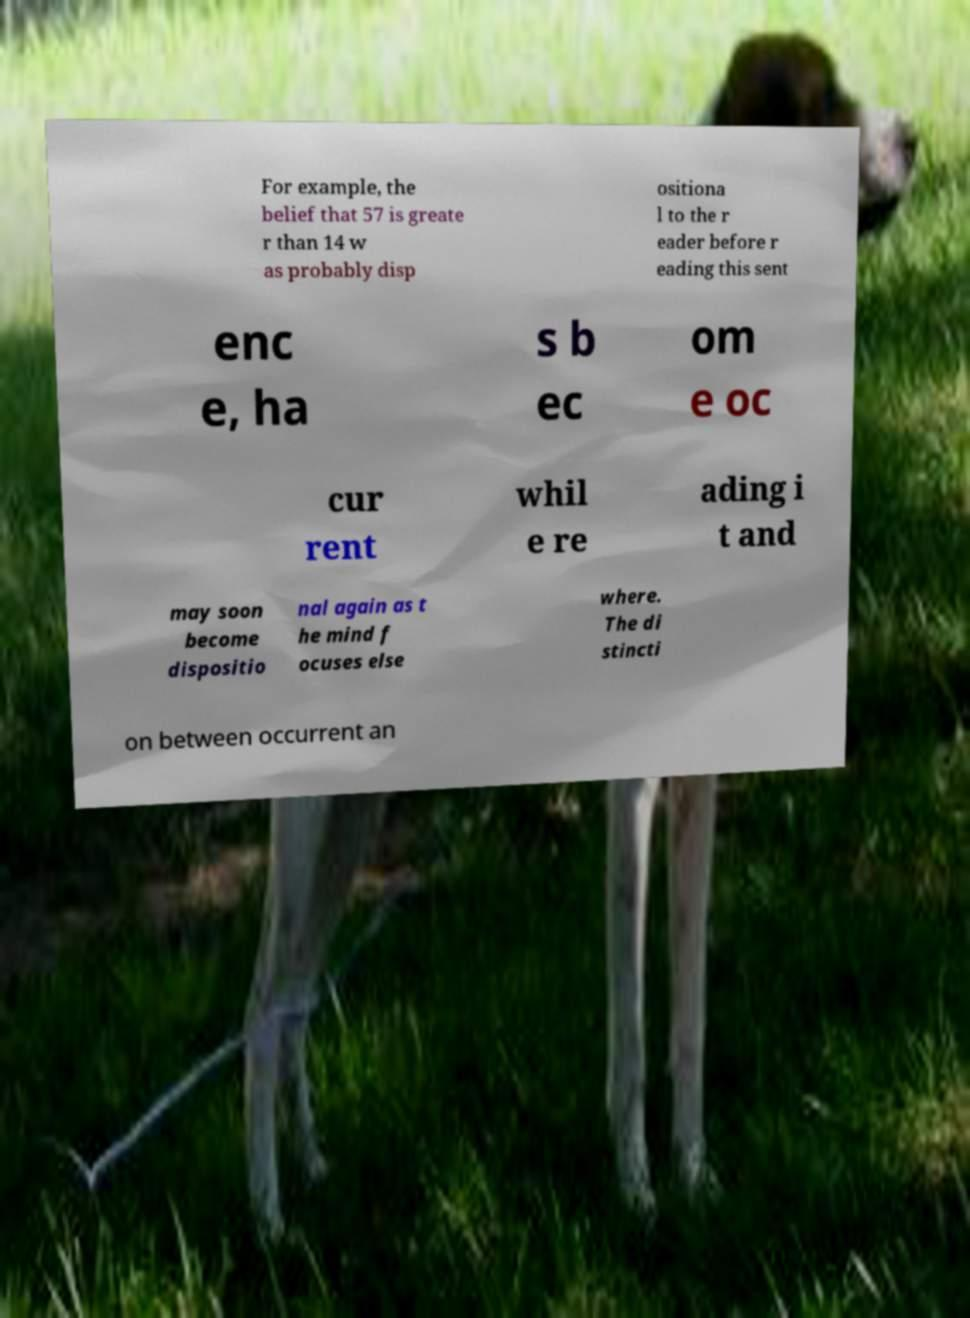There's text embedded in this image that I need extracted. Can you transcribe it verbatim? For example, the belief that 57 is greate r than 14 w as probably disp ositiona l to the r eader before r eading this sent enc e, ha s b ec om e oc cur rent whil e re ading i t and may soon become dispositio nal again as t he mind f ocuses else where. The di stincti on between occurrent an 